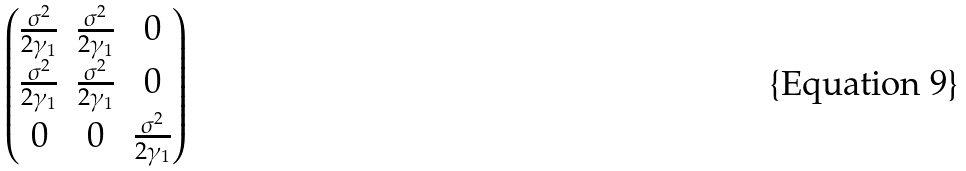Convert formula to latex. <formula><loc_0><loc_0><loc_500><loc_500>\begin{pmatrix} \frac { \sigma ^ { 2 } } { 2 \gamma _ { 1 } } & \frac { \sigma ^ { 2 } } { 2 \gamma _ { 1 } } & 0 \\ \frac { \sigma ^ { 2 } } { 2 \gamma _ { 1 } } & \frac { \sigma ^ { 2 } } { 2 \gamma _ { 1 } } & 0 \\ 0 & 0 & \frac { \sigma ^ { 2 } } { 2 \gamma _ { 1 } } \end{pmatrix}</formula> 